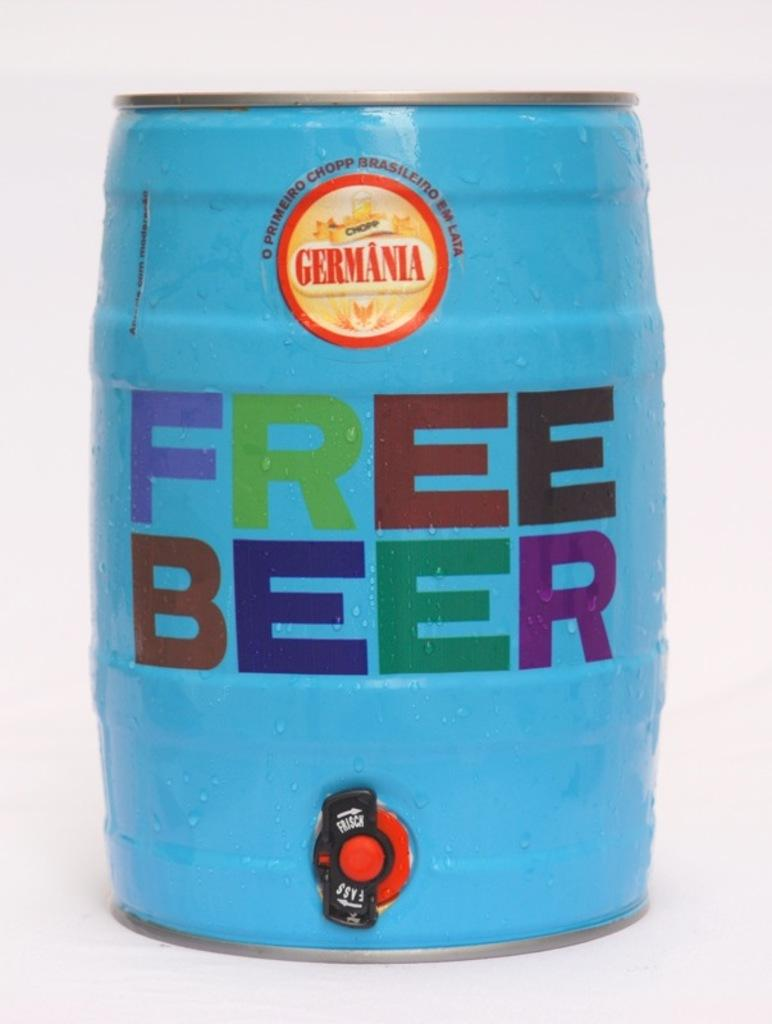Provide a one-sentence caption for the provided image. A blue keg with the text free beer on the middle in bold font. 